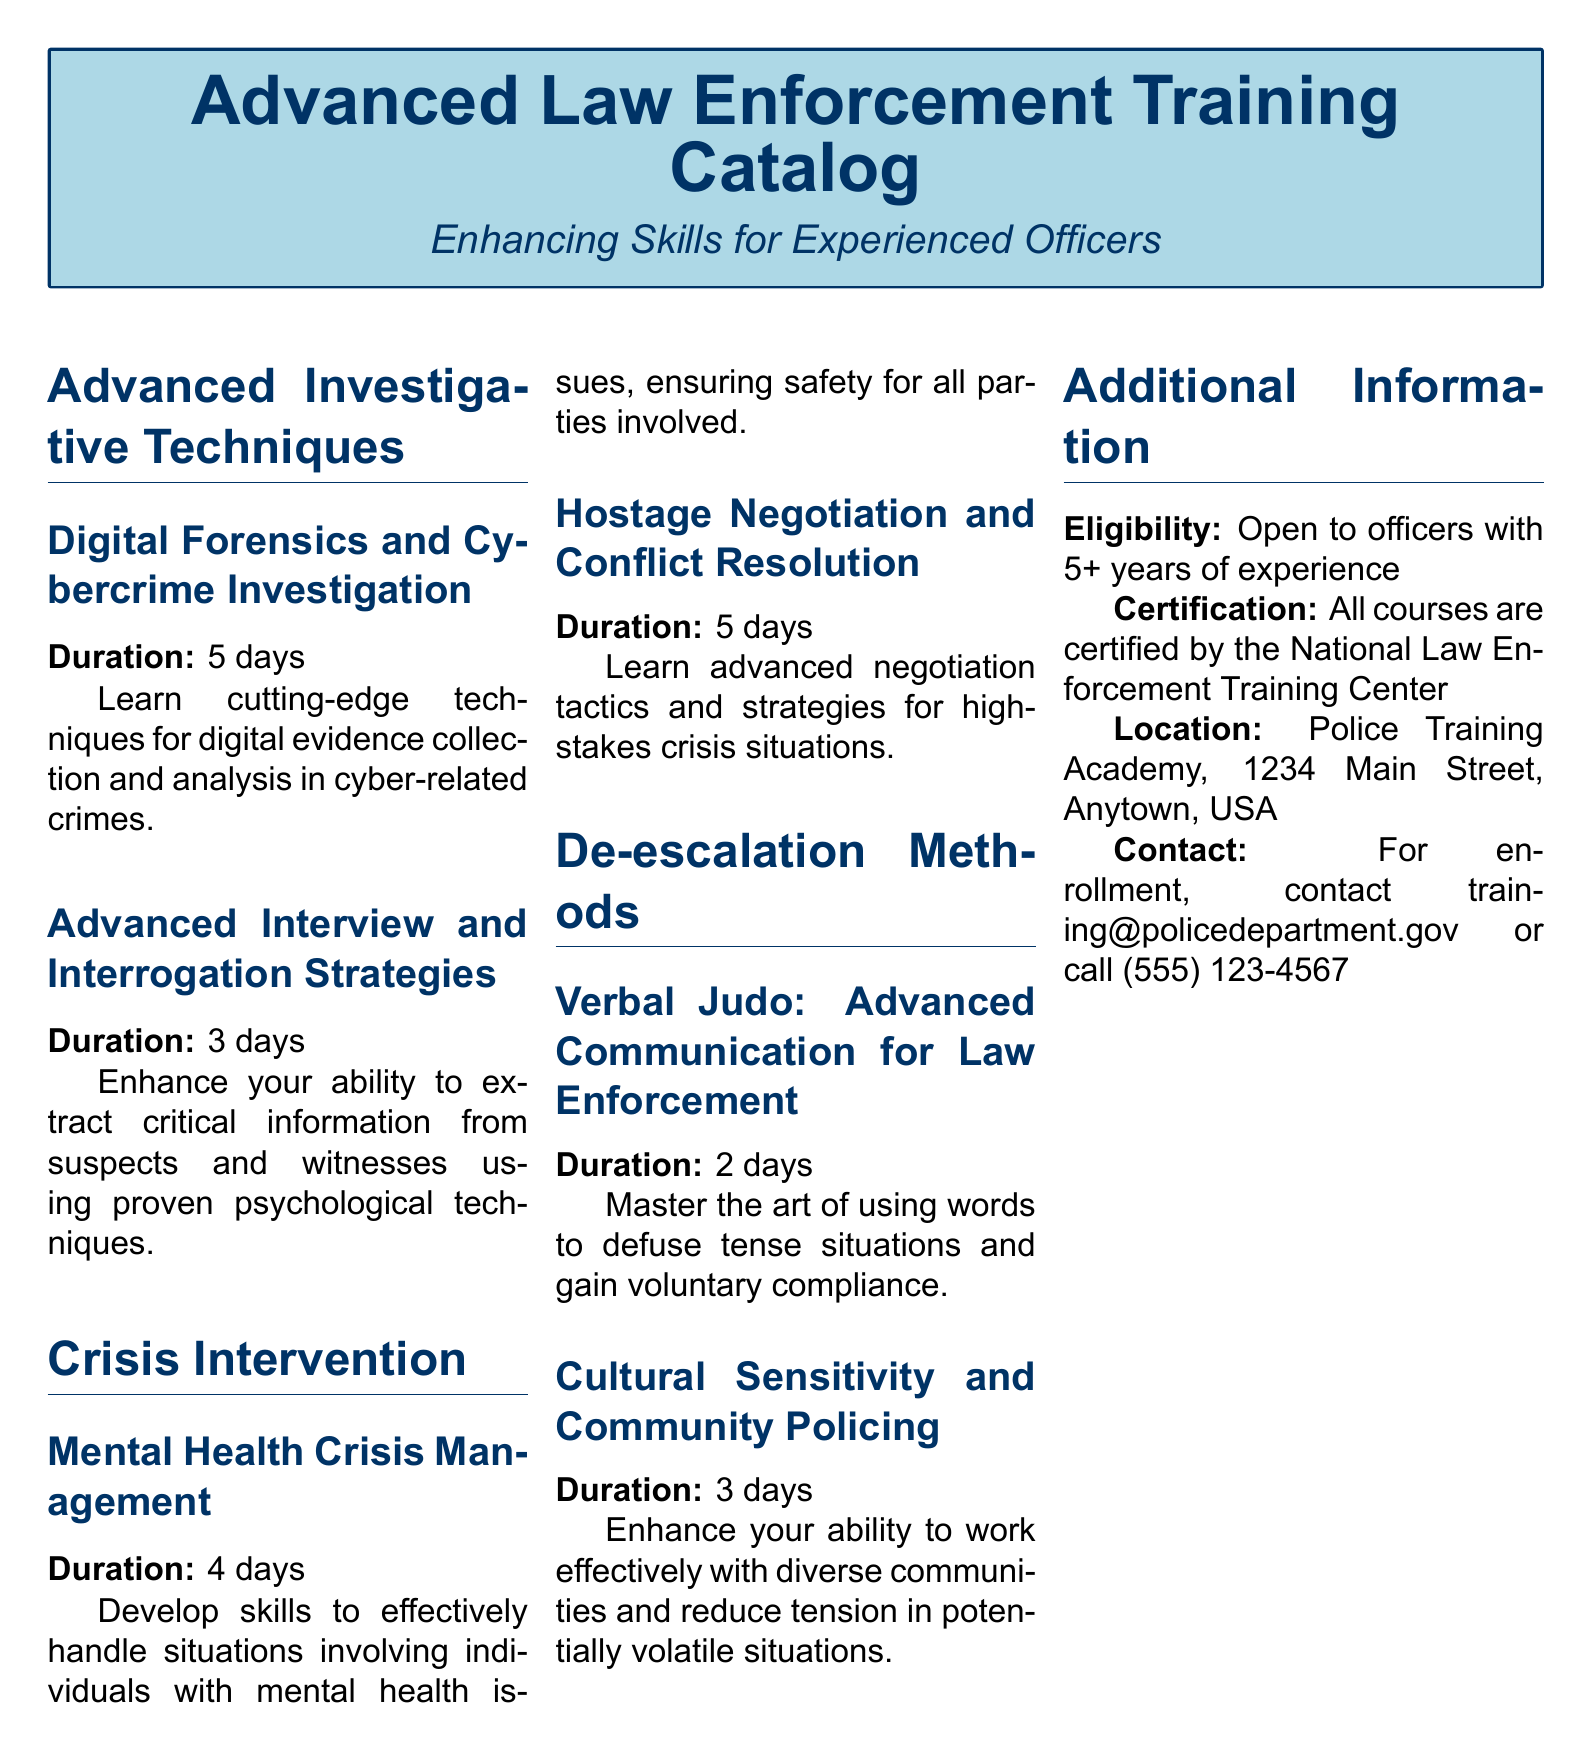What is the duration of the Digital Forensics course? The duration of the Digital Forensics course is specified in the document as 5 days.
Answer: 5 days What is the focus of the Advanced Interview Strategies course? The document describes the course as enhancing the ability to extract critical information using psychological techniques.
Answer: Extracting critical information What type of certification do all courses have? The document states that all courses are certified by a specific organization, which is the National Law Enforcement Training Center.
Answer: National Law Enforcement Training Center What is the location of the training academy? The document provides the address of the training academy, which is 1234 Main Street, Anytown, USA.
Answer: 1234 Main Street, Anytown, USA How many days is the Mental Health Crisis Management course? The duration of the Mental Health Crisis Management course is specified in the document as 4 days.
Answer: 4 days What is the eligibility requirement for the courses? The document mentions that the courses are open to officers with a certain level of experience, specifically 5+ years.
Answer: 5+ years of experience What is taught in the Cultural Sensitivity and Community Policing course? The document indicates that the course focuses on enhancing ability to work with diverse communities and reducing tension.
Answer: Working effectively with diverse communities How many courses are listed under Crisis Intervention? The document lists two courses under the Crisis Intervention section.
Answer: 2 courses What is the duration of the Verbal Judo course? The document states that the duration of the Verbal Judo course is 2 days.
Answer: 2 days 